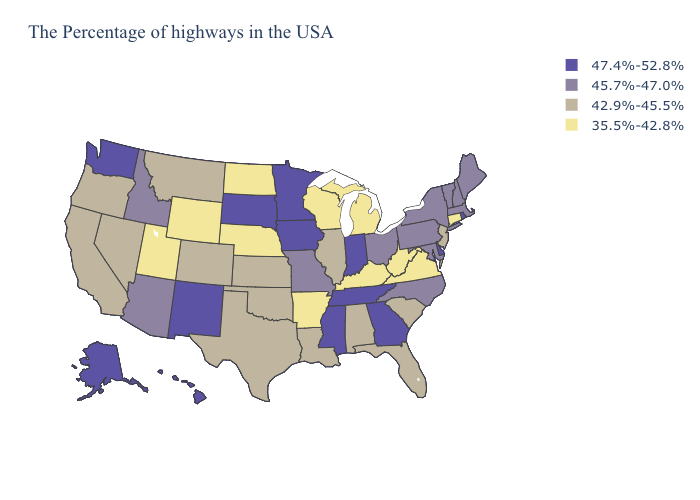What is the lowest value in the MidWest?
Give a very brief answer. 35.5%-42.8%. What is the lowest value in the USA?
Quick response, please. 35.5%-42.8%. Name the states that have a value in the range 42.9%-45.5%?
Answer briefly. New Jersey, South Carolina, Florida, Alabama, Illinois, Louisiana, Kansas, Oklahoma, Texas, Colorado, Montana, Nevada, California, Oregon. Name the states that have a value in the range 42.9%-45.5%?
Quick response, please. New Jersey, South Carolina, Florida, Alabama, Illinois, Louisiana, Kansas, Oklahoma, Texas, Colorado, Montana, Nevada, California, Oregon. Among the states that border Georgia , which have the lowest value?
Quick response, please. South Carolina, Florida, Alabama. What is the highest value in states that border Indiana?
Give a very brief answer. 45.7%-47.0%. Name the states that have a value in the range 42.9%-45.5%?
Quick response, please. New Jersey, South Carolina, Florida, Alabama, Illinois, Louisiana, Kansas, Oklahoma, Texas, Colorado, Montana, Nevada, California, Oregon. Does South Carolina have the lowest value in the South?
Write a very short answer. No. Name the states that have a value in the range 35.5%-42.8%?
Concise answer only. Connecticut, Virginia, West Virginia, Michigan, Kentucky, Wisconsin, Arkansas, Nebraska, North Dakota, Wyoming, Utah. Which states have the highest value in the USA?
Keep it brief. Rhode Island, Delaware, Georgia, Indiana, Tennessee, Mississippi, Minnesota, Iowa, South Dakota, New Mexico, Washington, Alaska, Hawaii. What is the value of Iowa?
Quick response, please. 47.4%-52.8%. Does the first symbol in the legend represent the smallest category?
Keep it brief. No. Name the states that have a value in the range 35.5%-42.8%?
Be succinct. Connecticut, Virginia, West Virginia, Michigan, Kentucky, Wisconsin, Arkansas, Nebraska, North Dakota, Wyoming, Utah. Does Connecticut have the lowest value in the Northeast?
Give a very brief answer. Yes. What is the value of Oregon?
Give a very brief answer. 42.9%-45.5%. 